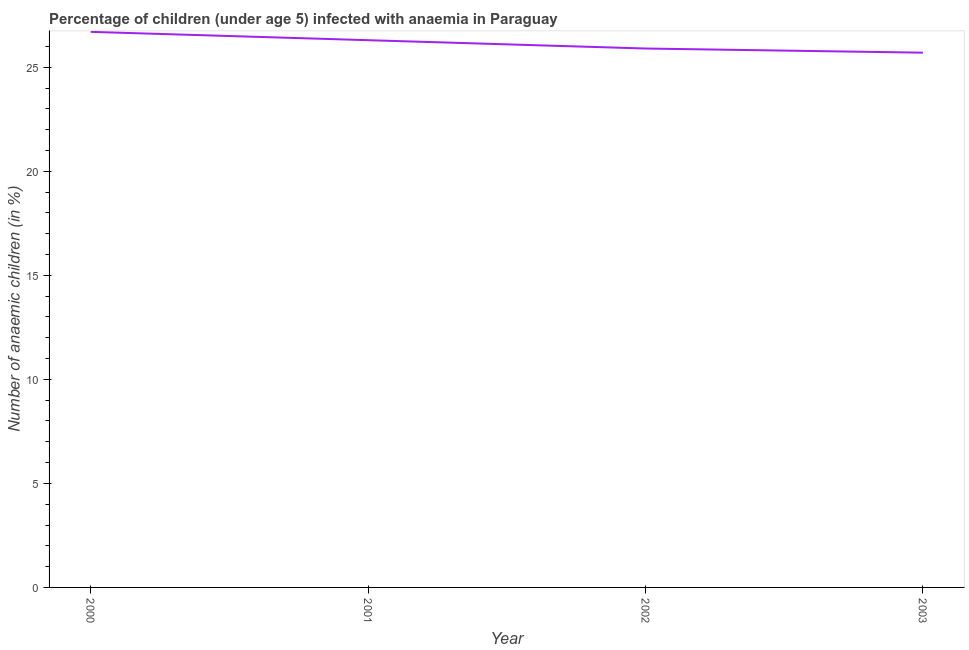What is the number of anaemic children in 2002?
Keep it short and to the point. 25.9. Across all years, what is the maximum number of anaemic children?
Offer a very short reply. 26.7. Across all years, what is the minimum number of anaemic children?
Your answer should be compact. 25.7. In which year was the number of anaemic children maximum?
Offer a very short reply. 2000. What is the sum of the number of anaemic children?
Your answer should be compact. 104.6. What is the average number of anaemic children per year?
Ensure brevity in your answer.  26.15. What is the median number of anaemic children?
Make the answer very short. 26.1. In how many years, is the number of anaemic children greater than 11 %?
Offer a very short reply. 4. What is the ratio of the number of anaemic children in 2000 to that in 2001?
Your answer should be very brief. 1.02. Is the difference between the number of anaemic children in 2000 and 2002 greater than the difference between any two years?
Provide a succinct answer. No. What is the difference between the highest and the second highest number of anaemic children?
Ensure brevity in your answer.  0.4. In how many years, is the number of anaemic children greater than the average number of anaemic children taken over all years?
Make the answer very short. 2. Does the number of anaemic children monotonically increase over the years?
Your response must be concise. No. How many years are there in the graph?
Provide a succinct answer. 4. What is the difference between two consecutive major ticks on the Y-axis?
Your answer should be compact. 5. Are the values on the major ticks of Y-axis written in scientific E-notation?
Give a very brief answer. No. What is the title of the graph?
Offer a terse response. Percentage of children (under age 5) infected with anaemia in Paraguay. What is the label or title of the Y-axis?
Offer a terse response. Number of anaemic children (in %). What is the Number of anaemic children (in %) in 2000?
Provide a short and direct response. 26.7. What is the Number of anaemic children (in %) of 2001?
Offer a very short reply. 26.3. What is the Number of anaemic children (in %) in 2002?
Provide a short and direct response. 25.9. What is the Number of anaemic children (in %) in 2003?
Your response must be concise. 25.7. What is the difference between the Number of anaemic children (in %) in 2000 and 2001?
Provide a short and direct response. 0.4. What is the difference between the Number of anaemic children (in %) in 2000 and 2002?
Your response must be concise. 0.8. What is the difference between the Number of anaemic children (in %) in 2001 and 2002?
Provide a succinct answer. 0.4. What is the difference between the Number of anaemic children (in %) in 2001 and 2003?
Your answer should be compact. 0.6. What is the ratio of the Number of anaemic children (in %) in 2000 to that in 2001?
Keep it short and to the point. 1.01. What is the ratio of the Number of anaemic children (in %) in 2000 to that in 2002?
Your answer should be very brief. 1.03. What is the ratio of the Number of anaemic children (in %) in 2000 to that in 2003?
Ensure brevity in your answer.  1.04. What is the ratio of the Number of anaemic children (in %) in 2001 to that in 2002?
Make the answer very short. 1.01. What is the ratio of the Number of anaemic children (in %) in 2001 to that in 2003?
Provide a short and direct response. 1.02. 